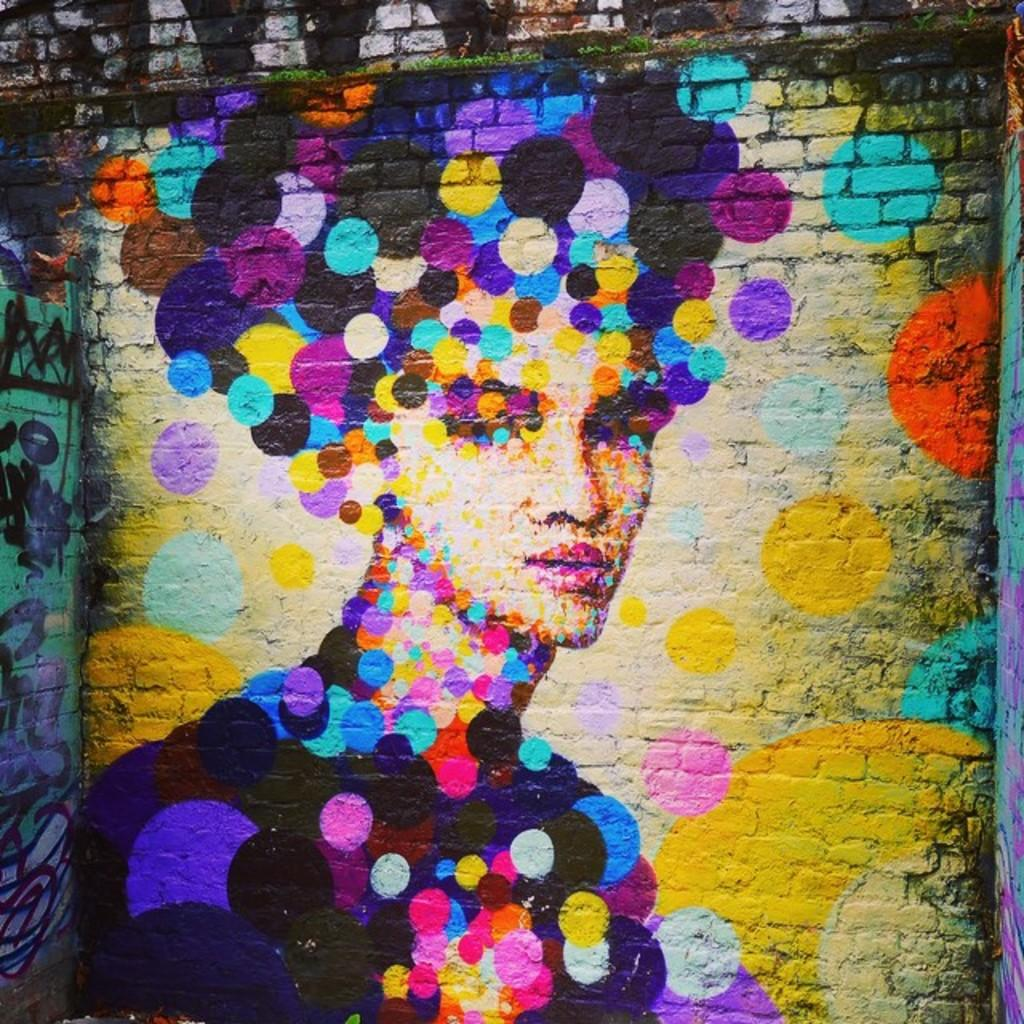What type of structure is visible in the image? There is a brick wall in the image. What is on the brick wall? The brick wall has paintings on it. Can you describe the content of the paintings? The paintings include a person and other things. Are there any squirrels swimming in the sea depicted in the paintings? There is no sea or squirrels present in the paintings; they depict a person and other things. 